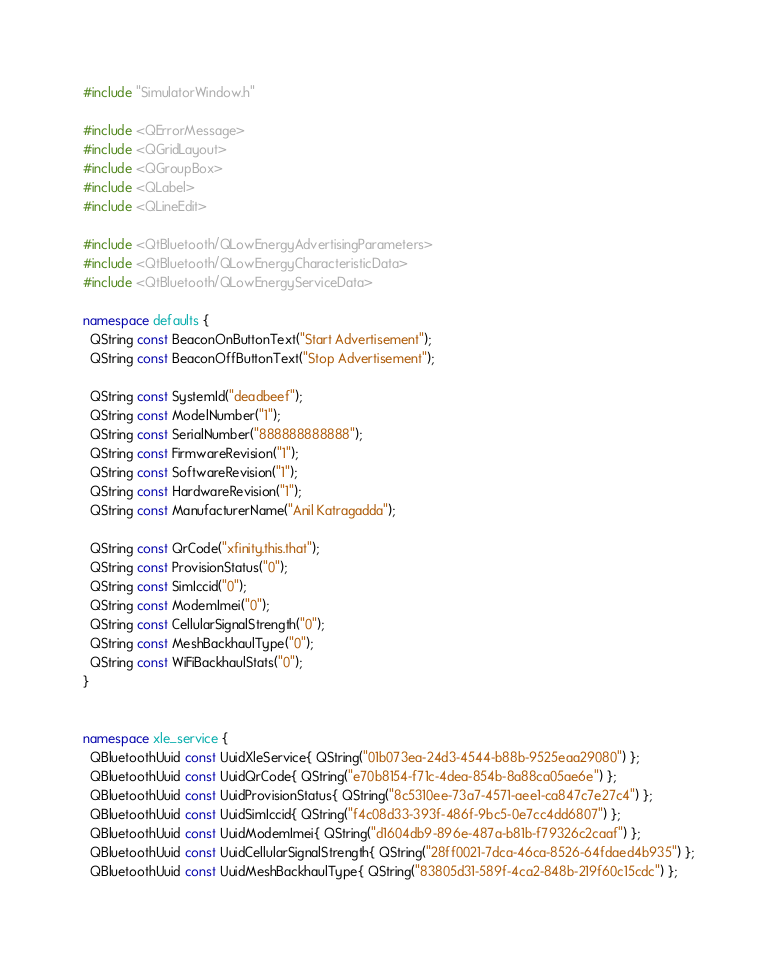Convert code to text. <code><loc_0><loc_0><loc_500><loc_500><_C++_>#include "SimulatorWindow.h"

#include <QErrorMessage>
#include <QGridLayout>
#include <QGroupBox>
#include <QLabel>
#include <QLineEdit>

#include <QtBluetooth/QLowEnergyAdvertisingParameters>
#include <QtBluetooth/QLowEnergyCharacteristicData>
#include <QtBluetooth/QLowEnergyServiceData>

namespace defaults {
  QString const BeaconOnButtonText("Start Advertisement");
  QString const BeaconOffButtonText("Stop Advertisement");

  QString const SystemId("deadbeef");
  QString const ModelNumber("1");
  QString const SerialNumber("888888888888");
  QString const FirmwareRevision("1");
  QString const SoftwareRevision("1");
  QString const HardwareRevision("1");
  QString const ManufacturerName("Anil Katragadda");

  QString const QrCode("xfinity.this.that");
  QString const ProvisionStatus("0");
  QString const SimIccid("0");
  QString const ModemImei("0");
  QString const CellularSignalStrength("0");
  QString const MeshBackhaulType("0");
  QString const WiFiBackhaulStats("0");
}


namespace xle_service {
  QBluetoothUuid const UuidXleService{ QString("01b073ea-24d3-4544-b88b-9525eaa29080") };
  QBluetoothUuid const UuidQrCode{ QString("e70b8154-f71c-4dea-854b-8a88ca05ae6e") };
  QBluetoothUuid const UuidProvisionStatus{ QString("8c5310ee-73a7-4571-aee1-ca847c7e27c4") };
  QBluetoothUuid const UuidSimIccid{ QString("f4c08d33-393f-486f-9bc5-0e7cc4dd6807") };
  QBluetoothUuid const UuidModemImei{ QString("d1604db9-896e-487a-b81b-f79326c2caaf") };
  QBluetoothUuid const UuidCellularSignalStrength{ QString("28ff0021-7dca-46ca-8526-64fdaed4b935") };
  QBluetoothUuid const UuidMeshBackhaulType{ QString("83805d31-589f-4ca2-848b-219f60c15cdc") };</code> 